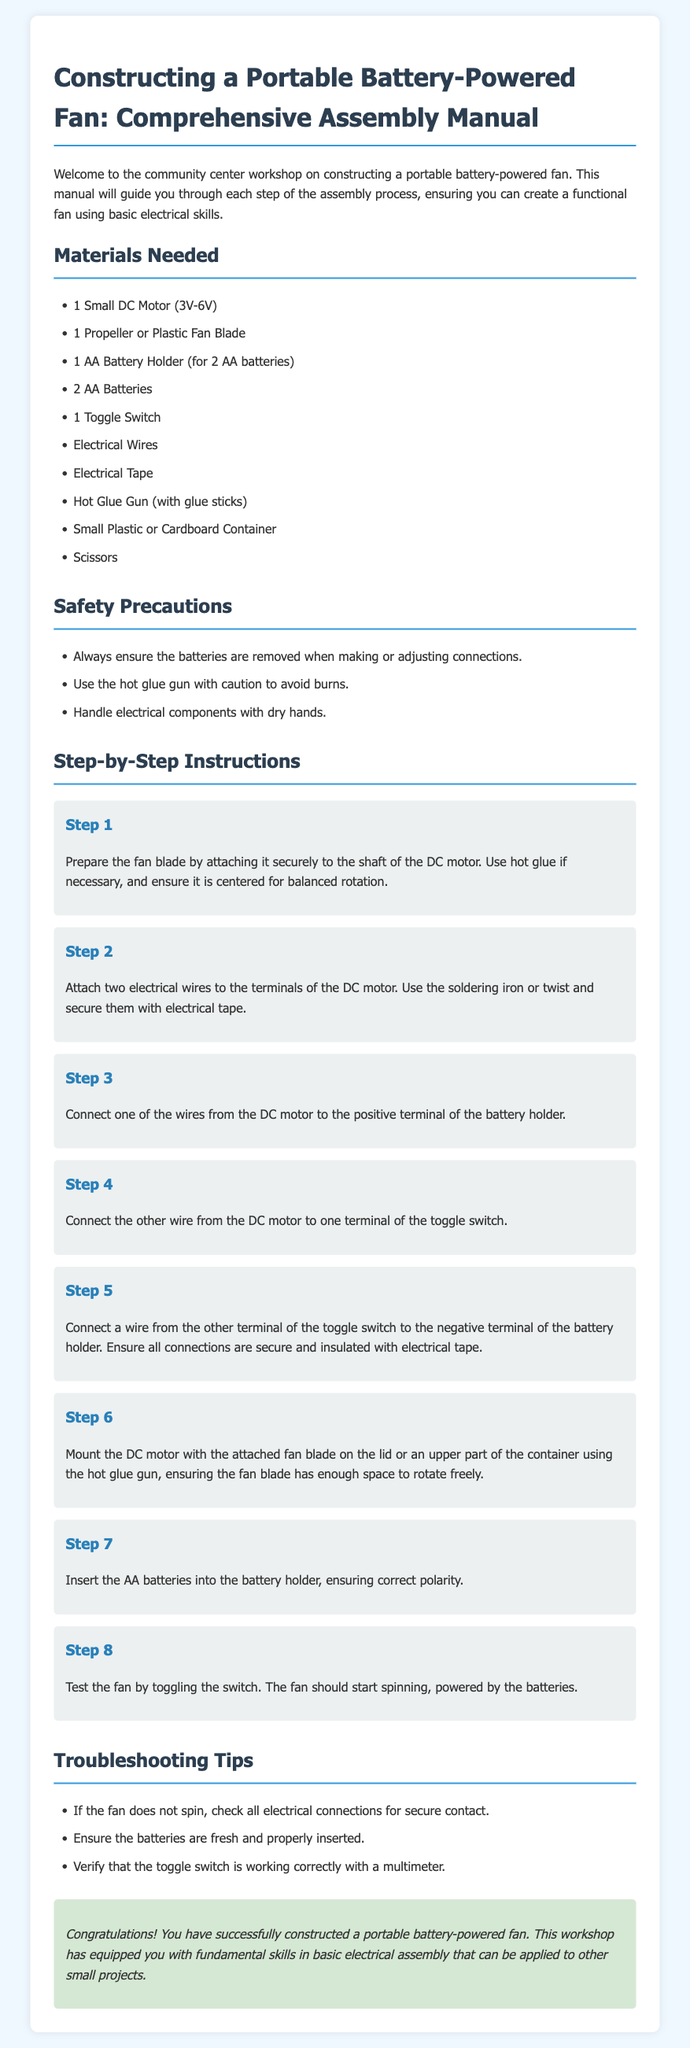What is the power range of the DC motor? The power range of the DC motor is specified in the document as 3V-6V.
Answer: 3V-6V How many AA batteries are required? The number of AA batteries listed in the materials needed is 2.
Answer: 2 What tool is recommended for securely attaching electrical components? The tool suggested for securing parts is the hot glue gun.
Answer: Hot glue gun What should be checked if the fan doesn't spin? If the fan does not spin, the document advises checking all electrical connections for secure contact.
Answer: Check connections In which step is the toggle switch connected? The toggle switch is connected in Step 4, where one wire from the DC motor is attached to it.
Answer: Step 4 What is used to ensure safety when handling components? The safety precaution advises to handle electrical components with dry hands.
Answer: Dry hands What container type is recommended for mounting the motor? The document recommends using a small plastic or cardboard container to mount the motor.
Answer: Small plastic or cardboard container How is the fan tested after assembly? The fan is tested by toggling the switch to see if it starts spinning.
Answer: Toggling the switch 